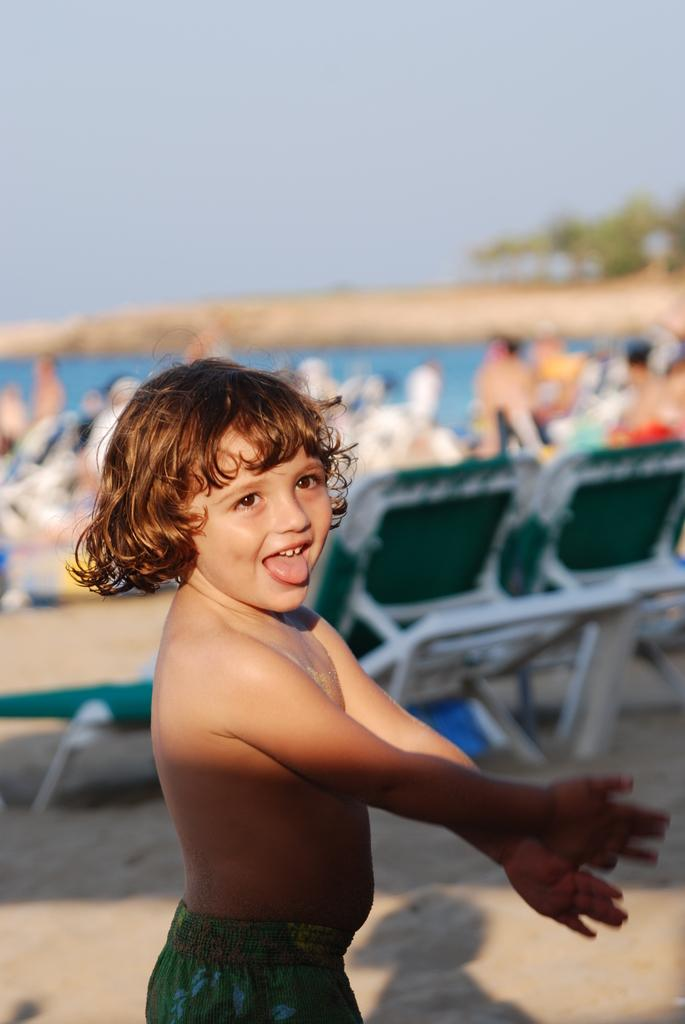Who is the main subject in the front of the image? There is a boy in the front of the image. What can be observed about the background of the image? The background of the image is blurry. What else can be seen in the background of the image? There are people, chairs, trees, and objects in the background of the image. What part of the natural environment is visible in the background of the image? The sky is visible in the background of the image. What type of wax can be seen melting on the boy's head in the image? There is no wax present in the image, and therefore no such activity can be observed. 